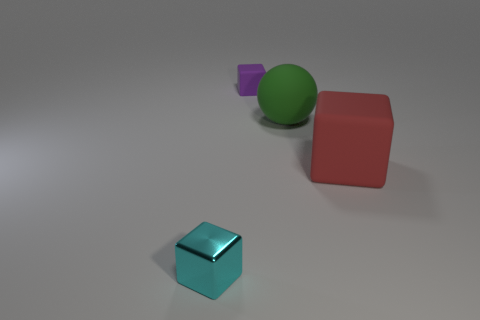Add 1 big green objects. How many objects exist? 5 Subtract all blocks. How many objects are left? 1 Subtract 0 brown cylinders. How many objects are left? 4 Subtract all big blocks. Subtract all large blocks. How many objects are left? 2 Add 4 large green rubber things. How many large green rubber things are left? 5 Add 4 small yellow cylinders. How many small yellow cylinders exist? 4 